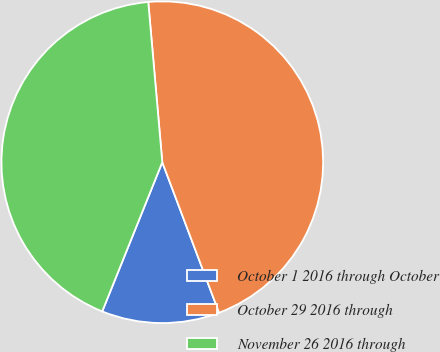Convert chart. <chart><loc_0><loc_0><loc_500><loc_500><pie_chart><fcel>October 1 2016 through October<fcel>October 29 2016 through<fcel>November 26 2016 through<nl><fcel>11.83%<fcel>45.65%<fcel>42.52%<nl></chart> 